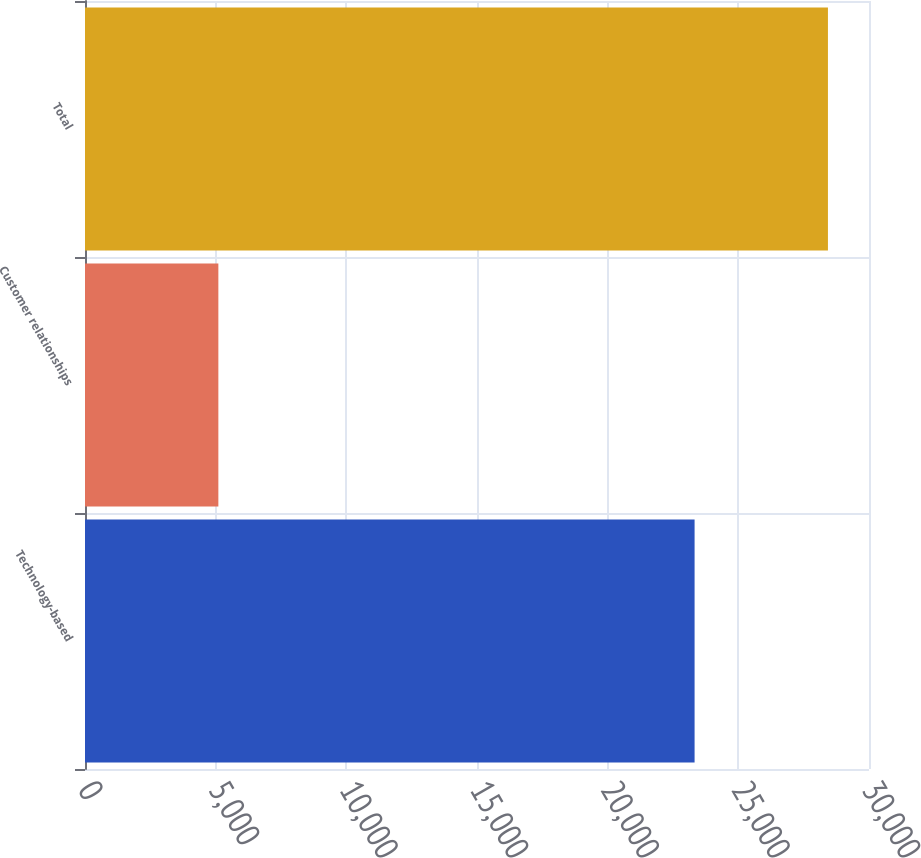Convert chart to OTSL. <chart><loc_0><loc_0><loc_500><loc_500><bar_chart><fcel>Technology-based<fcel>Customer relationships<fcel>Total<nl><fcel>23326<fcel>5103<fcel>28429<nl></chart> 